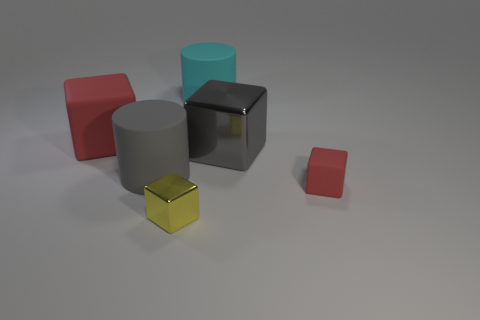Subtract 1 blocks. How many blocks are left? 3 Add 3 big cyan matte things. How many objects exist? 9 Subtract all cyan blocks. Subtract all cyan cylinders. How many blocks are left? 4 Subtract all cylinders. How many objects are left? 4 Add 6 metal things. How many metal things exist? 8 Subtract 0 blue cubes. How many objects are left? 6 Subtract all small purple matte cubes. Subtract all big gray rubber things. How many objects are left? 5 Add 3 tiny rubber things. How many tiny rubber things are left? 4 